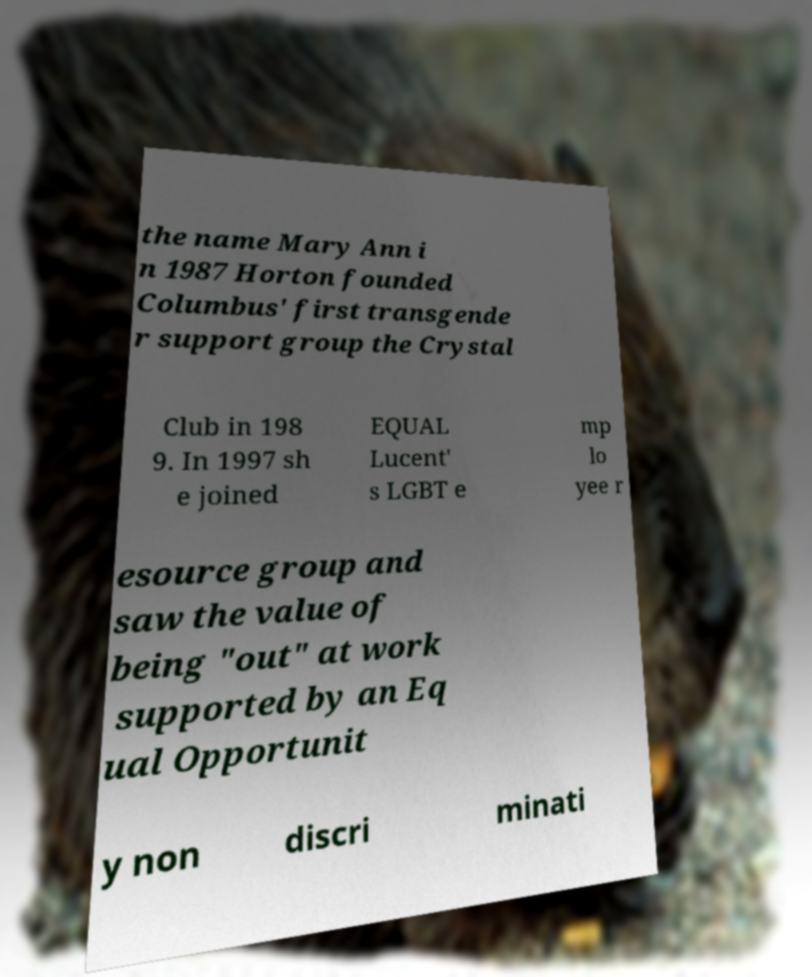There's text embedded in this image that I need extracted. Can you transcribe it verbatim? the name Mary Ann i n 1987 Horton founded Columbus' first transgende r support group the Crystal Club in 198 9. In 1997 sh e joined EQUAL Lucent' s LGBT e mp lo yee r esource group and saw the value of being "out" at work supported by an Eq ual Opportunit y non discri minati 